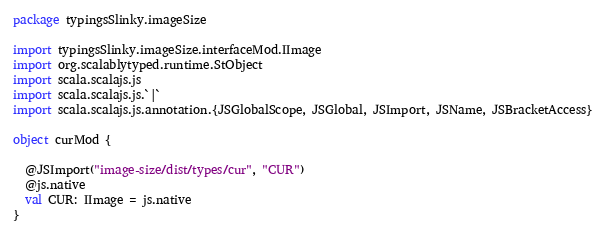Convert code to text. <code><loc_0><loc_0><loc_500><loc_500><_Scala_>package typingsSlinky.imageSize

import typingsSlinky.imageSize.interfaceMod.IImage
import org.scalablytyped.runtime.StObject
import scala.scalajs.js
import scala.scalajs.js.`|`
import scala.scalajs.js.annotation.{JSGlobalScope, JSGlobal, JSImport, JSName, JSBracketAccess}

object curMod {
  
  @JSImport("image-size/dist/types/cur", "CUR")
  @js.native
  val CUR: IImage = js.native
}
</code> 